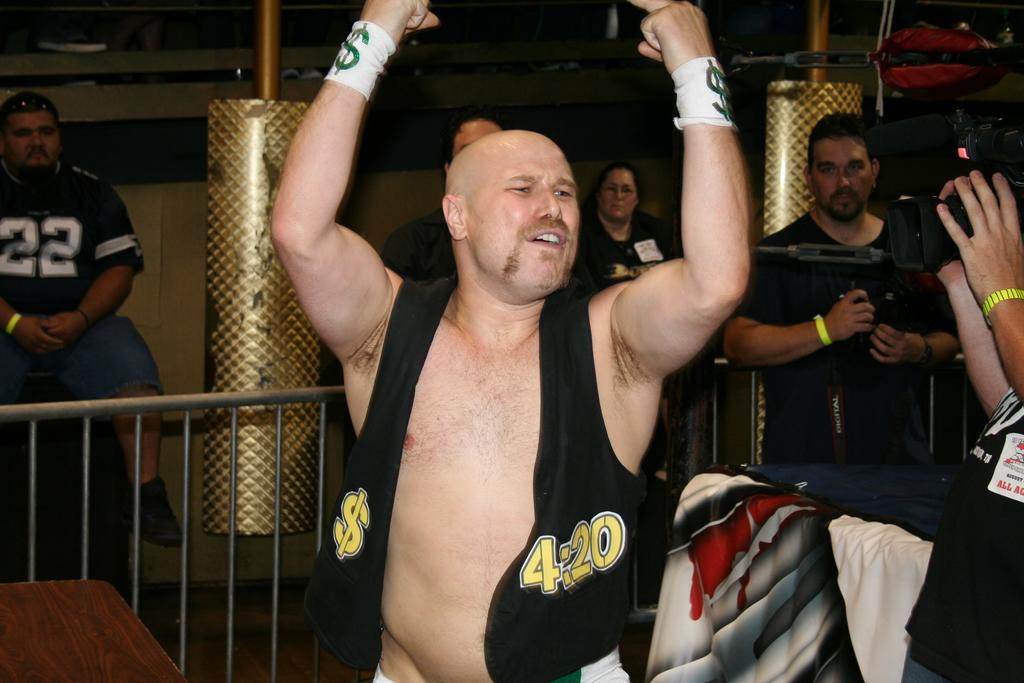<image>
Offer a succinct explanation of the picture presented. A wrestler wearing a 4:20 vest raises his arms in the air. 